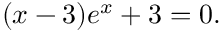Convert formula to latex. <formula><loc_0><loc_0><loc_500><loc_500>( x - 3 ) e ^ { x } + 3 = 0 .</formula> 